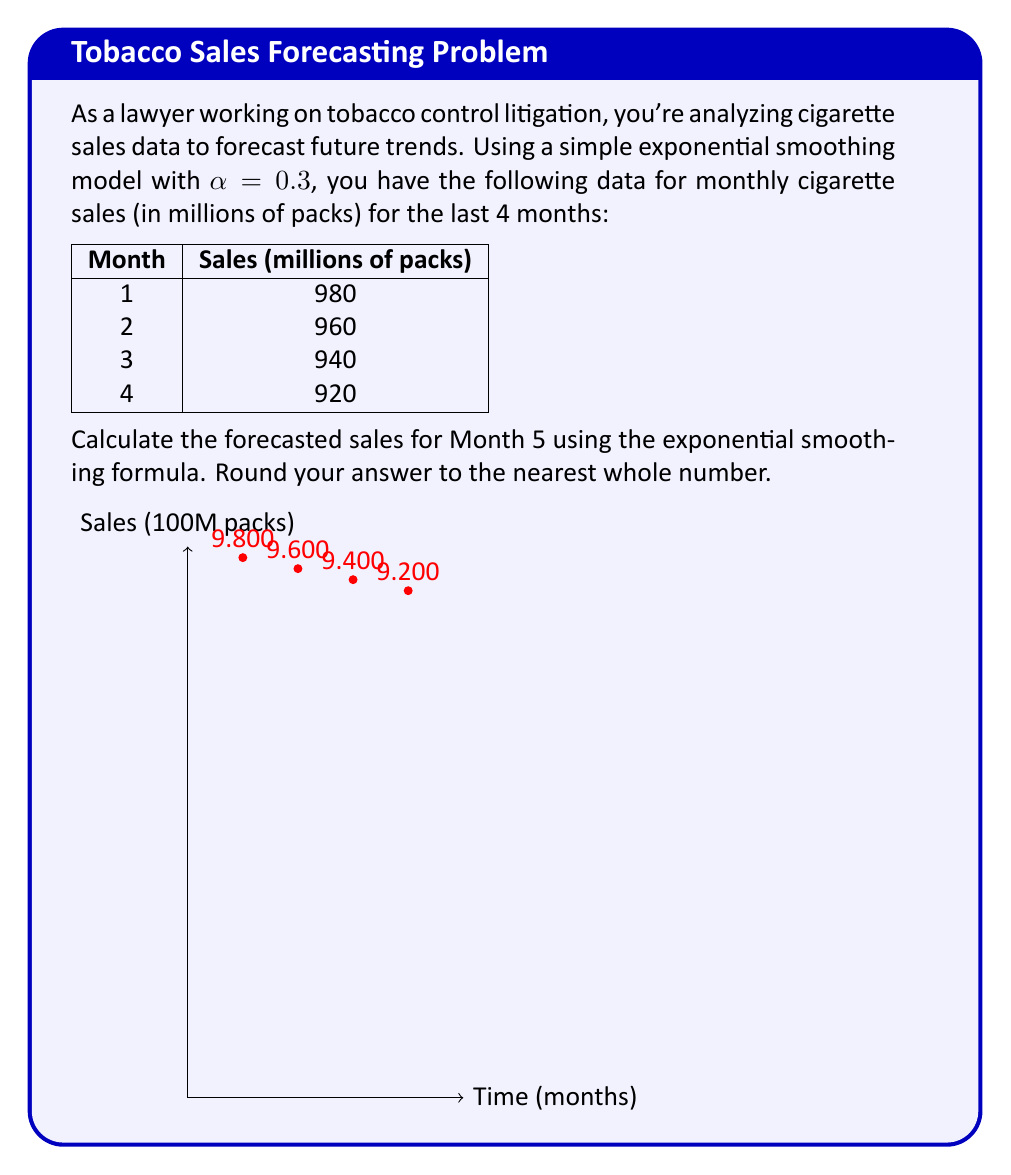Solve this math problem. Let's approach this step-by-step using the simple exponential smoothing formula:

1) The formula for simple exponential smoothing is:
   $$ F_{t+1} = \alpha Y_t + (1-\alpha)F_t $$
   where $F_{t+1}$ is the forecast for the next period, $Y_t$ is the actual value at time t, and $F_t$ is the forecast for the current period.

2) We're given $\alpha = 0.3$. We need to start with the first actual value as our initial forecast.

3) Let's calculate the forecasts for each month:

   Month 1: $F_1 = 980$ (initial forecast)
   
   Month 2: $F_2 = 0.3(980) + 0.7(980) = 980$

   Month 3: $F_3 = 0.3(960) + 0.7(980) = 974$

   Month 4: $F_4 = 0.3(940) + 0.7(974) = 963.8$

4) Now we can forecast Month 5:
   $F_5 = 0.3(920) + 0.7(963.8) = 276 + 674.66 = 950.66$

5) Rounding to the nearest whole number: 951 million packs.

This forecast suggests a continuing downward trend in cigarette sales, which could be valuable information for tobacco control litigation.
Answer: 951 million packs 